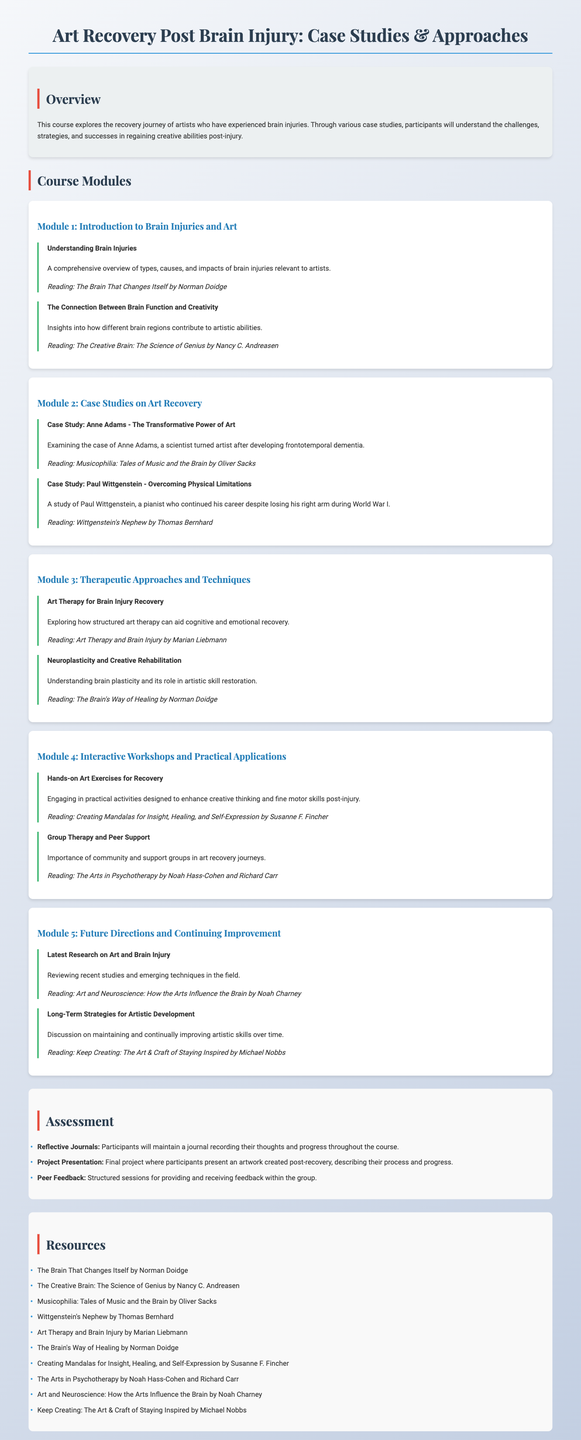What is the title of the syllabus? The title is specified in the header section of the document and introduces the main topic covered in the syllabus.
Answer: Art Recovery Post Brain Injury: Case Studies & Approaches What is the focus of Module 2? Module 2 pertains to a specific area of study highlighted in the syllabus and is labeled accordingly.
Answer: Case Studies on Art Recovery Who is the author of "Musicophilia: Tales of Music and the Brain"? The document lists specific readings along with their authors, providing direct attribution for each specified text.
Answer: Oliver Sacks What type of therapy is explored in Module 3? This part of the syllabus focuses on therapeutic techniques that relate to the recovery journey of artists.
Answer: Art Therapy How many case studies are presented in the syllabus? The document explicitly lists case studies within a module, allowing a clear count of the examples provided.
Answer: Two What is one of the assessment methods mentioned in the syllabus? Assessment methods are detailed in a specific section, providing insight into how participants will be evaluated.
Answer: Reflective Journals Which book discusses the connection between the arts and the brain? The syllabus includes a reading list that connects to the themes explored throughout the course.
Answer: Art and Neuroscience: How the Arts Influence the Brain What is emphasized in the Module 4 workshop? The focus is on specific practical applications that relate to the recovery process and creative engagement.
Answer: Hands-on Art Exercises for Recovery 